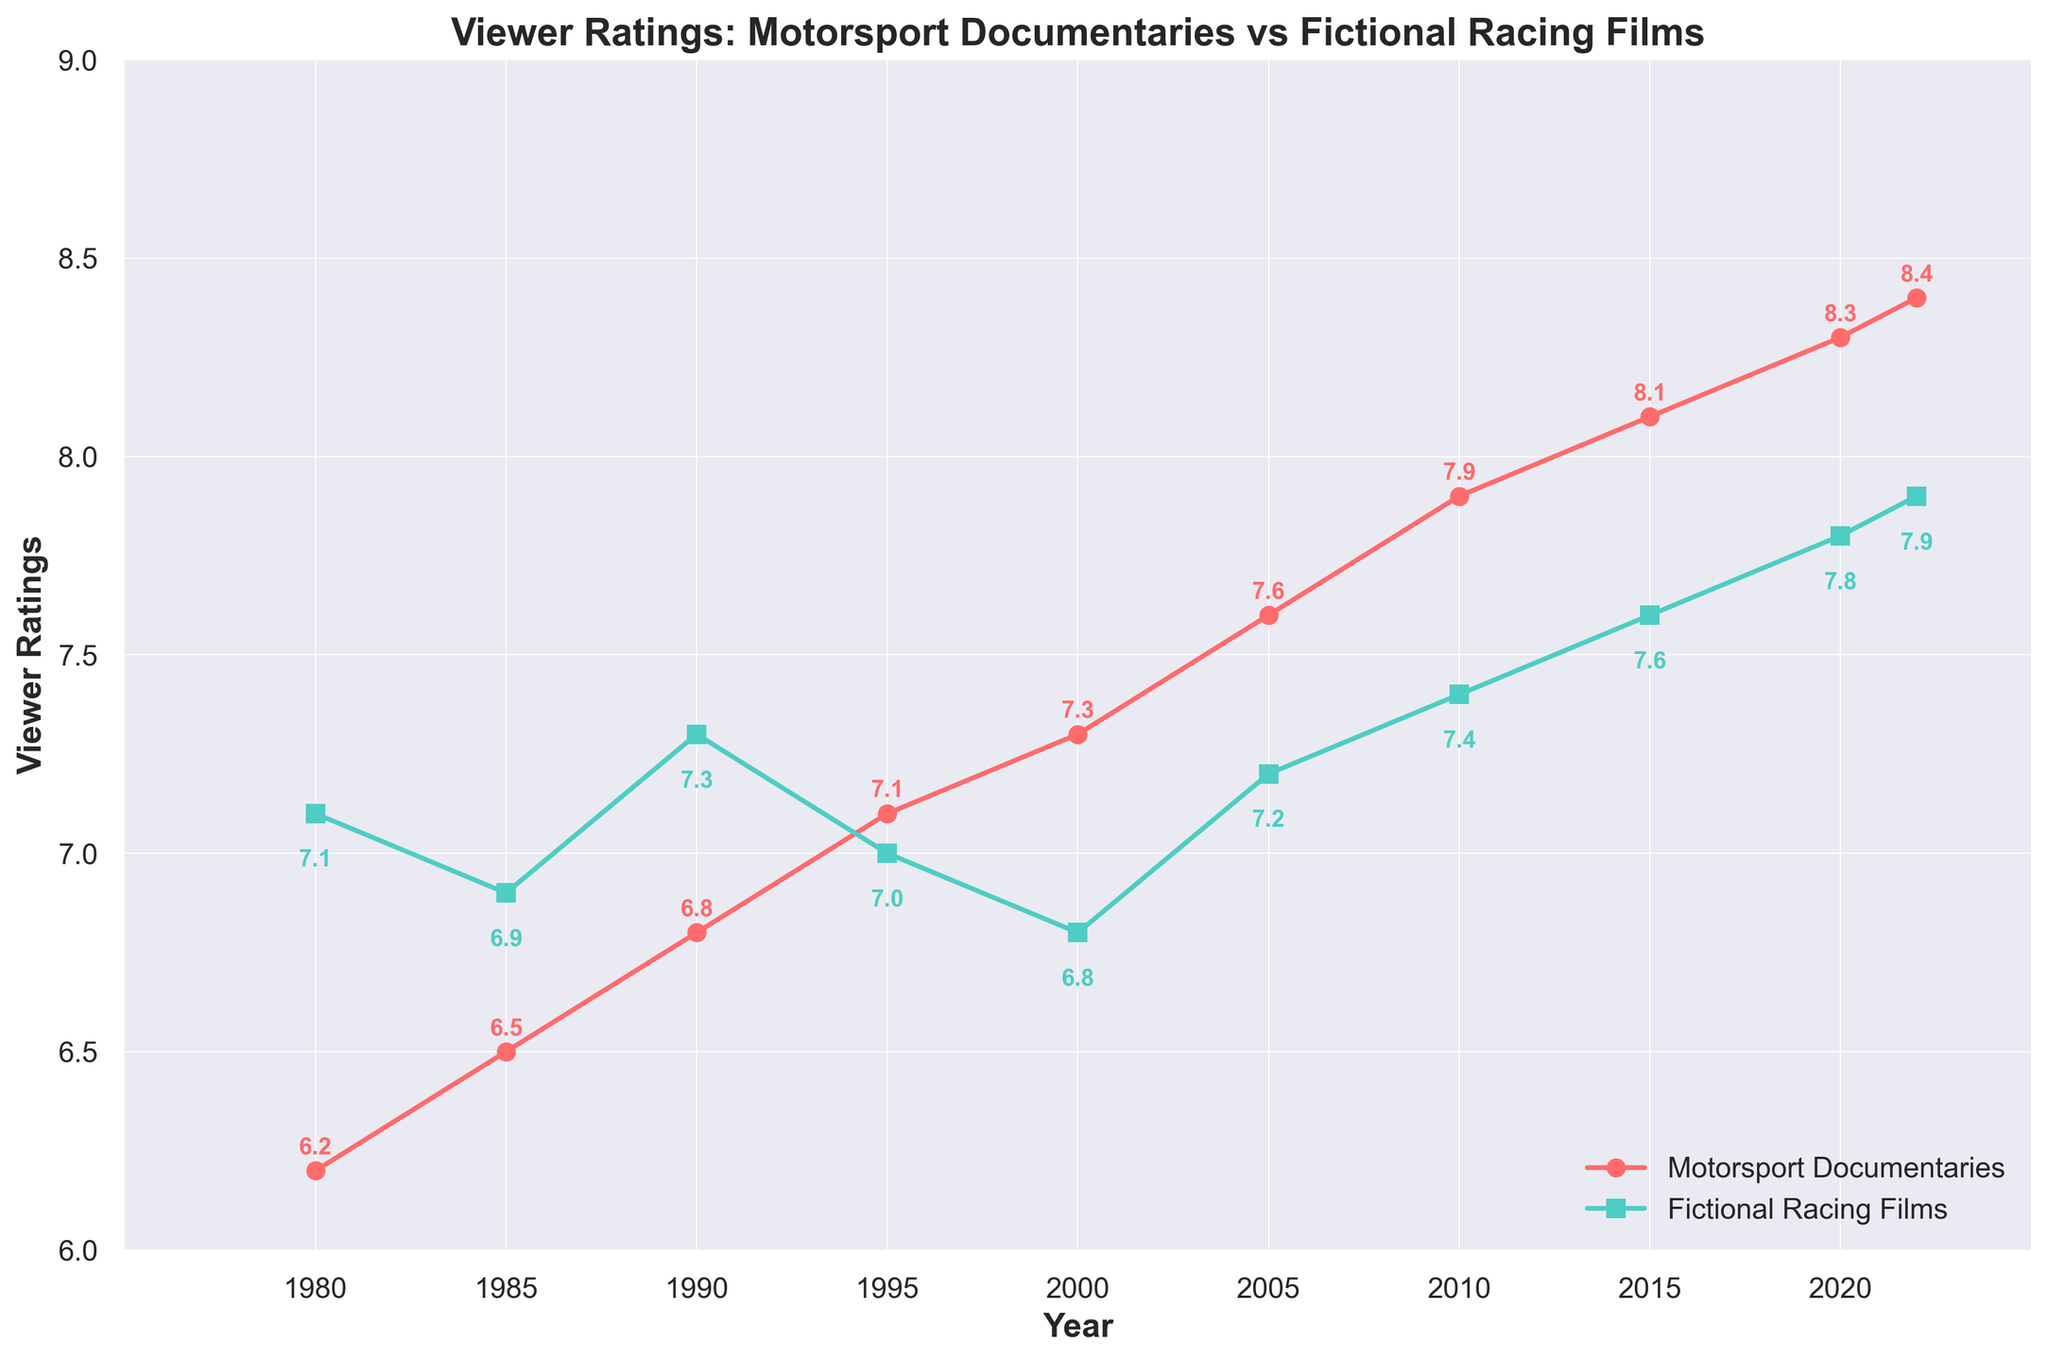What is the trend in viewer ratings for motorsport documentaries from 1980 to 2022? The viewer ratings for motorsport documentaries show a steady increase from 6.2 in 1980 to 8.4 in 2022. This indicates a consistent rise in their popularity and/or quality over this period.
Answer: Steady increase How do the 2010 viewer ratings for motorsport documentaries compare to those of fictional racing films? In 2010, the viewer ratings for motorsport documentaries were 7.9, while the ratings for fictional racing films were 7.4. Therefore, the documentaries had higher ratings at that point.
Answer: Documentaries had higher ratings In which year did fictional racing films have the highest viewer rating and what was the rating? The highest viewer rating for fictional racing films occurred in 2022, with a rating of 7.9.
Answer: 2022, 7.9 Calculate the average viewer rating of motorsport documentaries from 1980 to 2000. The viewer ratings for motorsport documentaries from 1980 to 2000 are: 6.2, 6.5, 6.8, 7.1, 7.3. The sum of these values is 33.9. Dividing this by 5 (the number of ratings) gives an average rating of 6.78.
Answer: 6.78 What has a greater increase in ratings from 1980 to 2022: motorsport documentaries or fictional racing films? The viewer rating for motorsport documentaries increased from 6.2 in 1980 to 8.4 in 2022, which is an increase of 2.2. Fictional racing films increased from 7.1 in 1980 to 7.9 in 2022, which is an increase of 0.8. Thus, motorsport documentaries had a greater increase.
Answer: Motorsport documentaries In which years did fictional racing films have a dip in viewer ratings compared to the previous period? Fictional racing films had a dip in ratings in 1985 (6.9) compared to 1980 (7.1), and in 2000 (6.8) compared to 1995 (7.0).
Answer: 1985, 2000 How much did the viewer rating of motorsport documentaries change between 1995 and 2022? The viewer rating of motorsport documentaries in 1995 was 7.1, and in 2022 it was 8.4. The change in rating is 8.4 - 7.1, which equals 1.3.
Answer: 1.3 Which category had more consistent viewer ratings over the observed period, and how do you determine that? Fictional racing films had more consistent viewer ratings, as evidenced by the smaller changes in ratings over time compared to motorsport documentaries, which showed a wider range of changes.
Answer: Fictional racing films What was the difference in viewer ratings between the two categories in the year 1980? In 1980, the viewer rating for motorsport documentaries was 6.2, and for fictional racing films, it was 7.1. The difference is 7.1 - 6.2, which equals 0.9.
Answer: 0.9 In the period from 2000 to 2020, which category shows a larger average viewer rating increase per interval of 5 years? From 2000 to 2020, motorsport documentaries increased their ratings by 7.3 to 8.3, which is a difference of 1.0 over 20 years (0.25 per 5 years). Fictional racing films increased from 6.8 to 7.8, which is also a difference of 1.0 over 20 years (0.25 per 5 years). Hence, both categories show the same average increase per 5-year interval.
Answer: Both are equal 